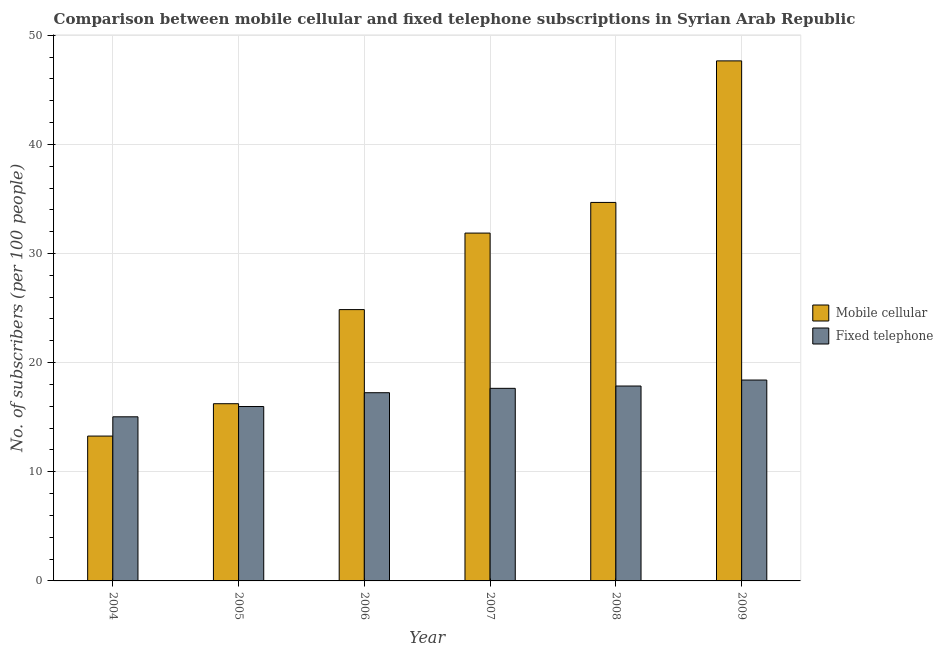How many different coloured bars are there?
Your response must be concise. 2. Are the number of bars per tick equal to the number of legend labels?
Your answer should be very brief. Yes. How many bars are there on the 1st tick from the left?
Make the answer very short. 2. How many bars are there on the 5th tick from the right?
Your answer should be compact. 2. In how many cases, is the number of bars for a given year not equal to the number of legend labels?
Offer a very short reply. 0. What is the number of fixed telephone subscribers in 2008?
Provide a succinct answer. 17.86. Across all years, what is the maximum number of mobile cellular subscribers?
Your answer should be compact. 47.65. Across all years, what is the minimum number of mobile cellular subscribers?
Your response must be concise. 13.27. What is the total number of fixed telephone subscribers in the graph?
Provide a short and direct response. 102.17. What is the difference between the number of fixed telephone subscribers in 2004 and that in 2005?
Give a very brief answer. -0.94. What is the difference between the number of fixed telephone subscribers in 2004 and the number of mobile cellular subscribers in 2009?
Make the answer very short. -3.37. What is the average number of fixed telephone subscribers per year?
Your response must be concise. 17.03. In how many years, is the number of mobile cellular subscribers greater than 6?
Keep it short and to the point. 6. What is the ratio of the number of mobile cellular subscribers in 2007 to that in 2008?
Offer a very short reply. 0.92. Is the number of mobile cellular subscribers in 2008 less than that in 2009?
Provide a short and direct response. Yes. Is the difference between the number of fixed telephone subscribers in 2008 and 2009 greater than the difference between the number of mobile cellular subscribers in 2008 and 2009?
Your response must be concise. No. What is the difference between the highest and the second highest number of fixed telephone subscribers?
Provide a succinct answer. 0.55. What is the difference between the highest and the lowest number of fixed telephone subscribers?
Keep it short and to the point. 3.37. In how many years, is the number of fixed telephone subscribers greater than the average number of fixed telephone subscribers taken over all years?
Provide a short and direct response. 4. What does the 2nd bar from the left in 2005 represents?
Offer a very short reply. Fixed telephone. What does the 1st bar from the right in 2008 represents?
Offer a terse response. Fixed telephone. Does the graph contain grids?
Give a very brief answer. Yes. Where does the legend appear in the graph?
Provide a succinct answer. Center right. How are the legend labels stacked?
Make the answer very short. Vertical. What is the title of the graph?
Provide a succinct answer. Comparison between mobile cellular and fixed telephone subscriptions in Syrian Arab Republic. Does "Automatic Teller Machines" appear as one of the legend labels in the graph?
Keep it short and to the point. No. What is the label or title of the X-axis?
Your response must be concise. Year. What is the label or title of the Y-axis?
Your answer should be very brief. No. of subscribers (per 100 people). What is the No. of subscribers (per 100 people) in Mobile cellular in 2004?
Your response must be concise. 13.27. What is the No. of subscribers (per 100 people) in Fixed telephone in 2004?
Your answer should be compact. 15.04. What is the No. of subscribers (per 100 people) in Mobile cellular in 2005?
Provide a short and direct response. 16.24. What is the No. of subscribers (per 100 people) in Fixed telephone in 2005?
Keep it short and to the point. 15.98. What is the No. of subscribers (per 100 people) in Mobile cellular in 2006?
Ensure brevity in your answer.  24.86. What is the No. of subscribers (per 100 people) in Fixed telephone in 2006?
Keep it short and to the point. 17.25. What is the No. of subscribers (per 100 people) of Mobile cellular in 2007?
Your answer should be very brief. 31.87. What is the No. of subscribers (per 100 people) in Fixed telephone in 2007?
Your answer should be compact. 17.65. What is the No. of subscribers (per 100 people) of Mobile cellular in 2008?
Offer a very short reply. 34.68. What is the No. of subscribers (per 100 people) in Fixed telephone in 2008?
Your response must be concise. 17.86. What is the No. of subscribers (per 100 people) in Mobile cellular in 2009?
Ensure brevity in your answer.  47.65. What is the No. of subscribers (per 100 people) in Fixed telephone in 2009?
Your answer should be compact. 18.41. Across all years, what is the maximum No. of subscribers (per 100 people) in Mobile cellular?
Provide a short and direct response. 47.65. Across all years, what is the maximum No. of subscribers (per 100 people) in Fixed telephone?
Ensure brevity in your answer.  18.41. Across all years, what is the minimum No. of subscribers (per 100 people) in Mobile cellular?
Provide a succinct answer. 13.27. Across all years, what is the minimum No. of subscribers (per 100 people) in Fixed telephone?
Keep it short and to the point. 15.04. What is the total No. of subscribers (per 100 people) of Mobile cellular in the graph?
Your answer should be very brief. 168.58. What is the total No. of subscribers (per 100 people) in Fixed telephone in the graph?
Your answer should be very brief. 102.17. What is the difference between the No. of subscribers (per 100 people) of Mobile cellular in 2004 and that in 2005?
Offer a very short reply. -2.97. What is the difference between the No. of subscribers (per 100 people) of Fixed telephone in 2004 and that in 2005?
Keep it short and to the point. -0.94. What is the difference between the No. of subscribers (per 100 people) of Mobile cellular in 2004 and that in 2006?
Your answer should be compact. -11.59. What is the difference between the No. of subscribers (per 100 people) in Fixed telephone in 2004 and that in 2006?
Offer a very short reply. -2.21. What is the difference between the No. of subscribers (per 100 people) of Mobile cellular in 2004 and that in 2007?
Offer a terse response. -18.6. What is the difference between the No. of subscribers (per 100 people) in Fixed telephone in 2004 and that in 2007?
Give a very brief answer. -2.61. What is the difference between the No. of subscribers (per 100 people) of Mobile cellular in 2004 and that in 2008?
Keep it short and to the point. -21.41. What is the difference between the No. of subscribers (per 100 people) of Fixed telephone in 2004 and that in 2008?
Your response must be concise. -2.82. What is the difference between the No. of subscribers (per 100 people) in Mobile cellular in 2004 and that in 2009?
Ensure brevity in your answer.  -34.38. What is the difference between the No. of subscribers (per 100 people) in Fixed telephone in 2004 and that in 2009?
Give a very brief answer. -3.37. What is the difference between the No. of subscribers (per 100 people) of Mobile cellular in 2005 and that in 2006?
Offer a terse response. -8.62. What is the difference between the No. of subscribers (per 100 people) of Fixed telephone in 2005 and that in 2006?
Provide a short and direct response. -1.27. What is the difference between the No. of subscribers (per 100 people) in Mobile cellular in 2005 and that in 2007?
Give a very brief answer. -15.63. What is the difference between the No. of subscribers (per 100 people) of Fixed telephone in 2005 and that in 2007?
Provide a succinct answer. -1.67. What is the difference between the No. of subscribers (per 100 people) of Mobile cellular in 2005 and that in 2008?
Provide a short and direct response. -18.44. What is the difference between the No. of subscribers (per 100 people) in Fixed telephone in 2005 and that in 2008?
Your response must be concise. -1.88. What is the difference between the No. of subscribers (per 100 people) in Mobile cellular in 2005 and that in 2009?
Your answer should be very brief. -31.41. What is the difference between the No. of subscribers (per 100 people) of Fixed telephone in 2005 and that in 2009?
Offer a very short reply. -2.43. What is the difference between the No. of subscribers (per 100 people) of Mobile cellular in 2006 and that in 2007?
Keep it short and to the point. -7.01. What is the difference between the No. of subscribers (per 100 people) in Fixed telephone in 2006 and that in 2007?
Offer a terse response. -0.4. What is the difference between the No. of subscribers (per 100 people) in Mobile cellular in 2006 and that in 2008?
Your response must be concise. -9.82. What is the difference between the No. of subscribers (per 100 people) of Fixed telephone in 2006 and that in 2008?
Your response must be concise. -0.61. What is the difference between the No. of subscribers (per 100 people) in Mobile cellular in 2006 and that in 2009?
Provide a short and direct response. -22.79. What is the difference between the No. of subscribers (per 100 people) of Fixed telephone in 2006 and that in 2009?
Provide a short and direct response. -1.16. What is the difference between the No. of subscribers (per 100 people) of Mobile cellular in 2007 and that in 2008?
Your response must be concise. -2.81. What is the difference between the No. of subscribers (per 100 people) in Fixed telephone in 2007 and that in 2008?
Your answer should be compact. -0.21. What is the difference between the No. of subscribers (per 100 people) of Mobile cellular in 2007 and that in 2009?
Your answer should be compact. -15.78. What is the difference between the No. of subscribers (per 100 people) in Fixed telephone in 2007 and that in 2009?
Ensure brevity in your answer.  -0.76. What is the difference between the No. of subscribers (per 100 people) of Mobile cellular in 2008 and that in 2009?
Your answer should be compact. -12.97. What is the difference between the No. of subscribers (per 100 people) in Fixed telephone in 2008 and that in 2009?
Your response must be concise. -0.55. What is the difference between the No. of subscribers (per 100 people) of Mobile cellular in 2004 and the No. of subscribers (per 100 people) of Fixed telephone in 2005?
Make the answer very short. -2.71. What is the difference between the No. of subscribers (per 100 people) in Mobile cellular in 2004 and the No. of subscribers (per 100 people) in Fixed telephone in 2006?
Make the answer very short. -3.97. What is the difference between the No. of subscribers (per 100 people) in Mobile cellular in 2004 and the No. of subscribers (per 100 people) in Fixed telephone in 2007?
Your response must be concise. -4.37. What is the difference between the No. of subscribers (per 100 people) of Mobile cellular in 2004 and the No. of subscribers (per 100 people) of Fixed telephone in 2008?
Provide a succinct answer. -4.59. What is the difference between the No. of subscribers (per 100 people) of Mobile cellular in 2004 and the No. of subscribers (per 100 people) of Fixed telephone in 2009?
Your answer should be very brief. -5.13. What is the difference between the No. of subscribers (per 100 people) of Mobile cellular in 2005 and the No. of subscribers (per 100 people) of Fixed telephone in 2006?
Provide a short and direct response. -1.01. What is the difference between the No. of subscribers (per 100 people) in Mobile cellular in 2005 and the No. of subscribers (per 100 people) in Fixed telephone in 2007?
Give a very brief answer. -1.41. What is the difference between the No. of subscribers (per 100 people) in Mobile cellular in 2005 and the No. of subscribers (per 100 people) in Fixed telephone in 2008?
Your answer should be very brief. -1.62. What is the difference between the No. of subscribers (per 100 people) of Mobile cellular in 2005 and the No. of subscribers (per 100 people) of Fixed telephone in 2009?
Provide a short and direct response. -2.17. What is the difference between the No. of subscribers (per 100 people) of Mobile cellular in 2006 and the No. of subscribers (per 100 people) of Fixed telephone in 2007?
Provide a short and direct response. 7.21. What is the difference between the No. of subscribers (per 100 people) of Mobile cellular in 2006 and the No. of subscribers (per 100 people) of Fixed telephone in 2008?
Ensure brevity in your answer.  7. What is the difference between the No. of subscribers (per 100 people) of Mobile cellular in 2006 and the No. of subscribers (per 100 people) of Fixed telephone in 2009?
Your response must be concise. 6.45. What is the difference between the No. of subscribers (per 100 people) in Mobile cellular in 2007 and the No. of subscribers (per 100 people) in Fixed telephone in 2008?
Offer a very short reply. 14.01. What is the difference between the No. of subscribers (per 100 people) of Mobile cellular in 2007 and the No. of subscribers (per 100 people) of Fixed telephone in 2009?
Offer a terse response. 13.47. What is the difference between the No. of subscribers (per 100 people) of Mobile cellular in 2008 and the No. of subscribers (per 100 people) of Fixed telephone in 2009?
Give a very brief answer. 16.27. What is the average No. of subscribers (per 100 people) in Mobile cellular per year?
Make the answer very short. 28.1. What is the average No. of subscribers (per 100 people) of Fixed telephone per year?
Give a very brief answer. 17.03. In the year 2004, what is the difference between the No. of subscribers (per 100 people) in Mobile cellular and No. of subscribers (per 100 people) in Fixed telephone?
Your answer should be compact. -1.77. In the year 2005, what is the difference between the No. of subscribers (per 100 people) in Mobile cellular and No. of subscribers (per 100 people) in Fixed telephone?
Your answer should be very brief. 0.26. In the year 2006, what is the difference between the No. of subscribers (per 100 people) in Mobile cellular and No. of subscribers (per 100 people) in Fixed telephone?
Keep it short and to the point. 7.62. In the year 2007, what is the difference between the No. of subscribers (per 100 people) in Mobile cellular and No. of subscribers (per 100 people) in Fixed telephone?
Make the answer very short. 14.23. In the year 2008, what is the difference between the No. of subscribers (per 100 people) of Mobile cellular and No. of subscribers (per 100 people) of Fixed telephone?
Offer a very short reply. 16.82. In the year 2009, what is the difference between the No. of subscribers (per 100 people) of Mobile cellular and No. of subscribers (per 100 people) of Fixed telephone?
Keep it short and to the point. 29.25. What is the ratio of the No. of subscribers (per 100 people) in Mobile cellular in 2004 to that in 2005?
Keep it short and to the point. 0.82. What is the ratio of the No. of subscribers (per 100 people) in Fixed telephone in 2004 to that in 2005?
Give a very brief answer. 0.94. What is the ratio of the No. of subscribers (per 100 people) of Mobile cellular in 2004 to that in 2006?
Ensure brevity in your answer.  0.53. What is the ratio of the No. of subscribers (per 100 people) of Fixed telephone in 2004 to that in 2006?
Provide a short and direct response. 0.87. What is the ratio of the No. of subscribers (per 100 people) in Mobile cellular in 2004 to that in 2007?
Your response must be concise. 0.42. What is the ratio of the No. of subscribers (per 100 people) of Fixed telephone in 2004 to that in 2007?
Provide a short and direct response. 0.85. What is the ratio of the No. of subscribers (per 100 people) in Mobile cellular in 2004 to that in 2008?
Ensure brevity in your answer.  0.38. What is the ratio of the No. of subscribers (per 100 people) in Fixed telephone in 2004 to that in 2008?
Give a very brief answer. 0.84. What is the ratio of the No. of subscribers (per 100 people) of Mobile cellular in 2004 to that in 2009?
Provide a succinct answer. 0.28. What is the ratio of the No. of subscribers (per 100 people) in Fixed telephone in 2004 to that in 2009?
Ensure brevity in your answer.  0.82. What is the ratio of the No. of subscribers (per 100 people) in Mobile cellular in 2005 to that in 2006?
Your answer should be very brief. 0.65. What is the ratio of the No. of subscribers (per 100 people) of Fixed telephone in 2005 to that in 2006?
Keep it short and to the point. 0.93. What is the ratio of the No. of subscribers (per 100 people) of Mobile cellular in 2005 to that in 2007?
Offer a terse response. 0.51. What is the ratio of the No. of subscribers (per 100 people) in Fixed telephone in 2005 to that in 2007?
Your answer should be compact. 0.91. What is the ratio of the No. of subscribers (per 100 people) in Mobile cellular in 2005 to that in 2008?
Provide a succinct answer. 0.47. What is the ratio of the No. of subscribers (per 100 people) in Fixed telephone in 2005 to that in 2008?
Provide a succinct answer. 0.89. What is the ratio of the No. of subscribers (per 100 people) in Mobile cellular in 2005 to that in 2009?
Keep it short and to the point. 0.34. What is the ratio of the No. of subscribers (per 100 people) of Fixed telephone in 2005 to that in 2009?
Your answer should be very brief. 0.87. What is the ratio of the No. of subscribers (per 100 people) of Mobile cellular in 2006 to that in 2007?
Provide a succinct answer. 0.78. What is the ratio of the No. of subscribers (per 100 people) of Fixed telephone in 2006 to that in 2007?
Provide a short and direct response. 0.98. What is the ratio of the No. of subscribers (per 100 people) in Mobile cellular in 2006 to that in 2008?
Your answer should be compact. 0.72. What is the ratio of the No. of subscribers (per 100 people) of Fixed telephone in 2006 to that in 2008?
Ensure brevity in your answer.  0.97. What is the ratio of the No. of subscribers (per 100 people) in Mobile cellular in 2006 to that in 2009?
Your response must be concise. 0.52. What is the ratio of the No. of subscribers (per 100 people) of Fixed telephone in 2006 to that in 2009?
Your response must be concise. 0.94. What is the ratio of the No. of subscribers (per 100 people) in Mobile cellular in 2007 to that in 2008?
Keep it short and to the point. 0.92. What is the ratio of the No. of subscribers (per 100 people) of Fixed telephone in 2007 to that in 2008?
Your response must be concise. 0.99. What is the ratio of the No. of subscribers (per 100 people) of Mobile cellular in 2007 to that in 2009?
Your answer should be compact. 0.67. What is the ratio of the No. of subscribers (per 100 people) of Fixed telephone in 2007 to that in 2009?
Ensure brevity in your answer.  0.96. What is the ratio of the No. of subscribers (per 100 people) in Mobile cellular in 2008 to that in 2009?
Ensure brevity in your answer.  0.73. What is the ratio of the No. of subscribers (per 100 people) of Fixed telephone in 2008 to that in 2009?
Your answer should be very brief. 0.97. What is the difference between the highest and the second highest No. of subscribers (per 100 people) in Mobile cellular?
Offer a terse response. 12.97. What is the difference between the highest and the second highest No. of subscribers (per 100 people) in Fixed telephone?
Give a very brief answer. 0.55. What is the difference between the highest and the lowest No. of subscribers (per 100 people) of Mobile cellular?
Give a very brief answer. 34.38. What is the difference between the highest and the lowest No. of subscribers (per 100 people) of Fixed telephone?
Ensure brevity in your answer.  3.37. 